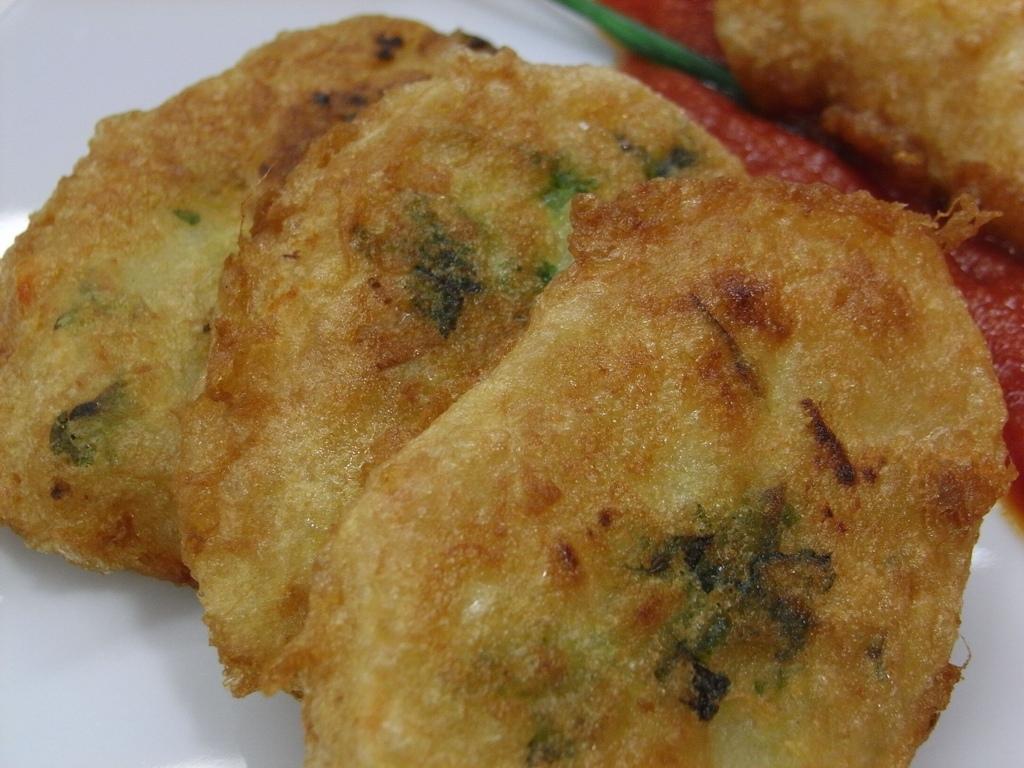How would you summarize this image in a sentence or two? In this picture we can see food and it is looks like sauce. 